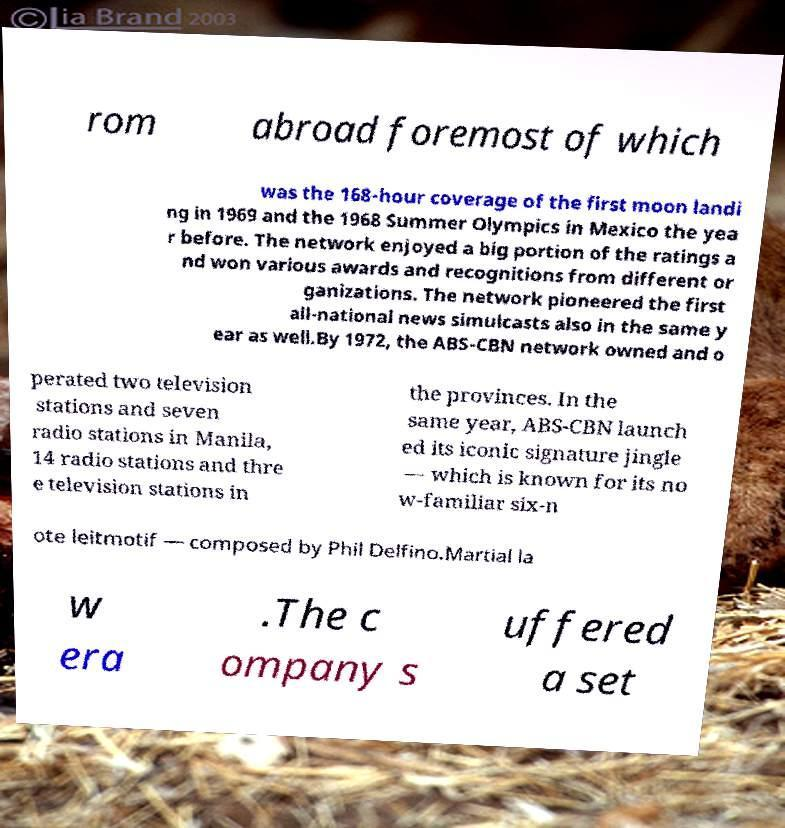What messages or text are displayed in this image? I need them in a readable, typed format. rom abroad foremost of which was the 168-hour coverage of the first moon landi ng in 1969 and the 1968 Summer Olympics in Mexico the yea r before. The network enjoyed a big portion of the ratings a nd won various awards and recognitions from different or ganizations. The network pioneered the first all-national news simulcasts also in the same y ear as well.By 1972, the ABS-CBN network owned and o perated two television stations and seven radio stations in Manila, 14 radio stations and thre e television stations in the provinces. In the same year, ABS-CBN launch ed its iconic signature jingle — which is known for its no w-familiar six-n ote leitmotif — composed by Phil Delfino.Martial la w era .The c ompany s uffered a set 